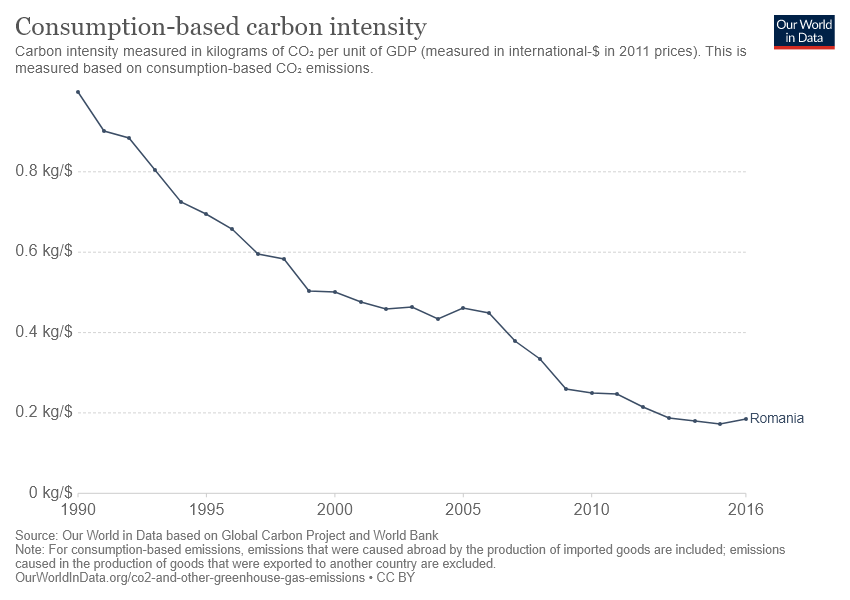Identify some key points in this picture. The line graph represents a country, which is Romania. The year with the highest carbon density as measured by consumption in Romania was recorded in [year]. 